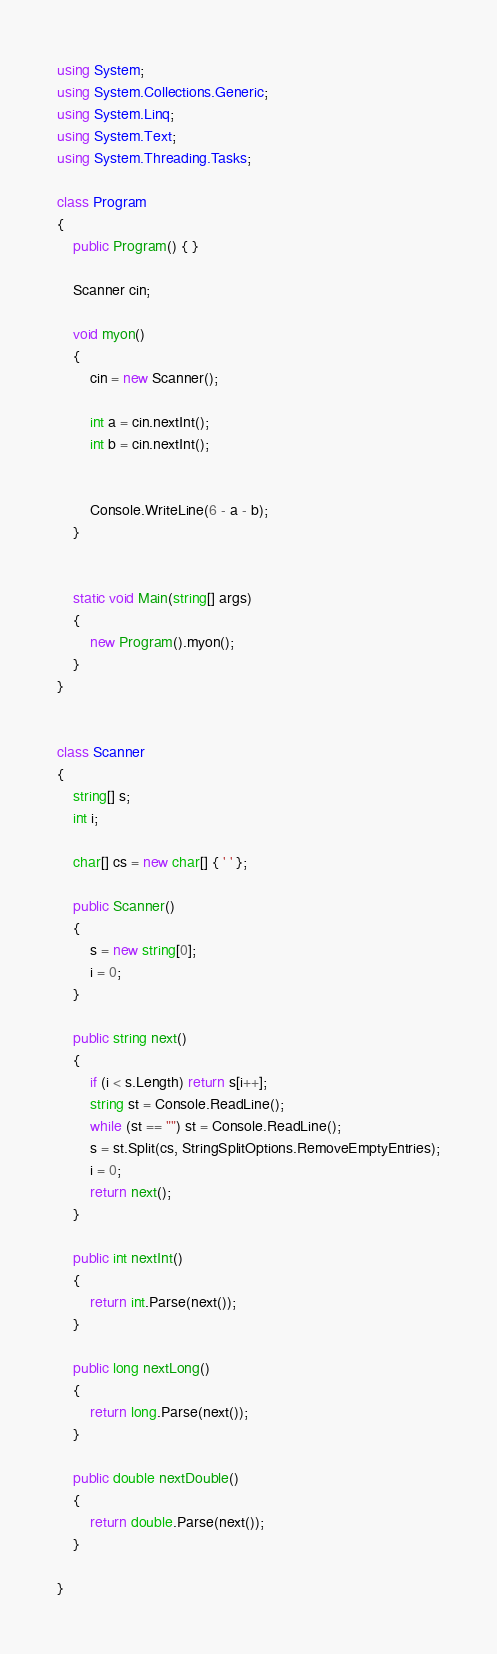<code> <loc_0><loc_0><loc_500><loc_500><_C#_>using System;
using System.Collections.Generic;
using System.Linq;
using System.Text;
using System.Threading.Tasks;

class Program
{
    public Program() { }

    Scanner cin;

    void myon()
    {
        cin = new Scanner();

        int a = cin.nextInt();
        int b = cin.nextInt();


        Console.WriteLine(6 - a - b);        
    }


    static void Main(string[] args)
    {
        new Program().myon();
    }
}


class Scanner
{
    string[] s;
    int i;

    char[] cs = new char[] { ' ' };

    public Scanner()
    {
        s = new string[0];
        i = 0;
    }

    public string next()
    {
        if (i < s.Length) return s[i++];
        string st = Console.ReadLine();
        while (st == "") st = Console.ReadLine();
        s = st.Split(cs, StringSplitOptions.RemoveEmptyEntries);
        i = 0;
        return next();
    }

    public int nextInt()
    {
        return int.Parse(next());
    }

    public long nextLong()
    {
        return long.Parse(next());
    }

    public double nextDouble()
    {
        return double.Parse(next());
    }

}</code> 